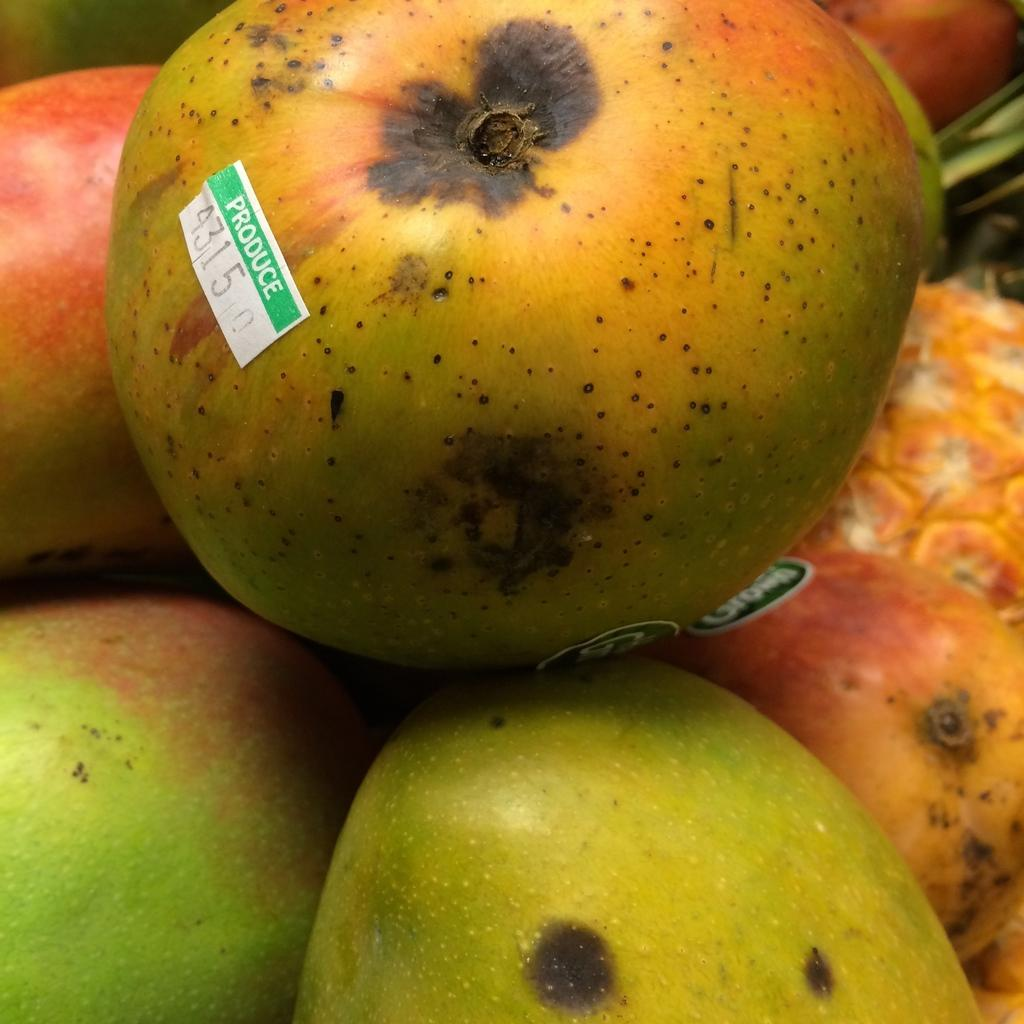What type of fruit is present in the image? There are apples in the image. Can you describe any additional features of the fruit? There is a label on the fruit. What color is the crayon used to draw on the steam in the image? There is no crayon or steam present in the image; it only features apples with a label. 